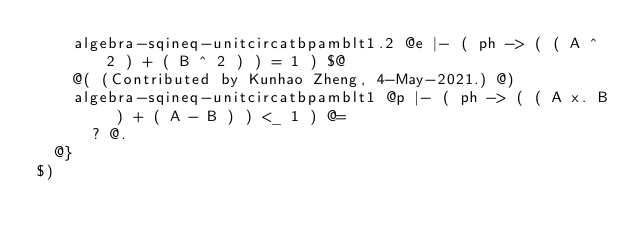Convert code to text. <code><loc_0><loc_0><loc_500><loc_500><_ObjectiveC_>    algebra-sqineq-unitcircatbpamblt1.2 @e |- ( ph -> ( ( A ^ 2 ) + ( B ^ 2 ) ) = 1 ) $@
    @( (Contributed by Kunhao Zheng, 4-May-2021.) @)
    algebra-sqineq-unitcircatbpamblt1 @p |- ( ph -> ( ( A x. B ) + ( A - B ) ) <_ 1 ) @=
      ? @.
  @}
$)
</code> 